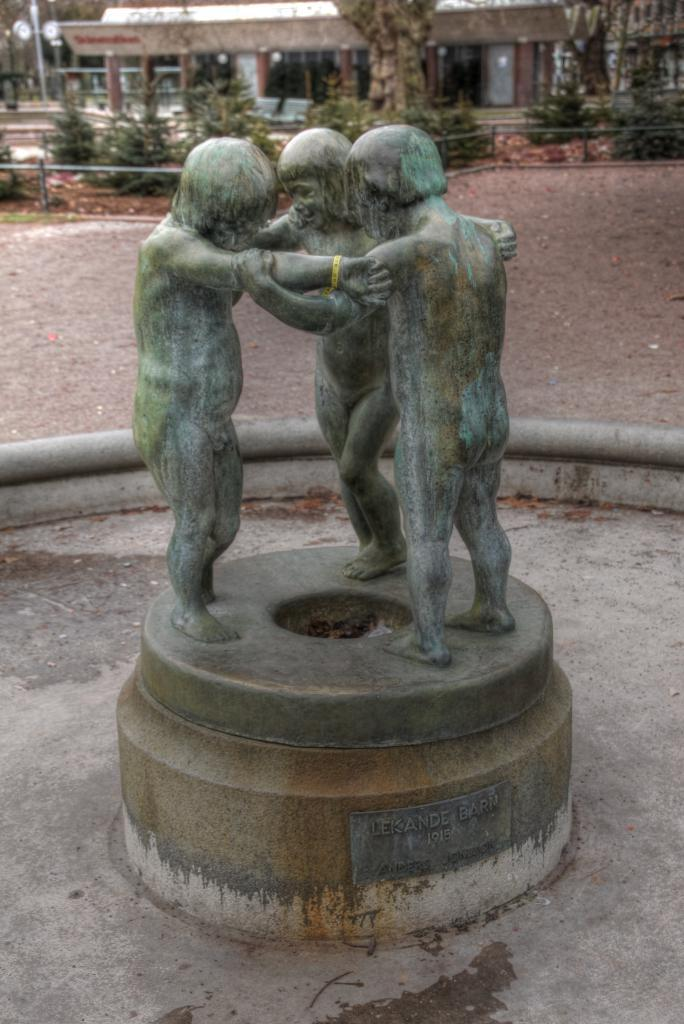What is located at the bottom of the image? There is a statue at the bottom of the image. What can be seen in the background of the image? There are trees and a building in the background of the image. Can you tell me how many farmers are visible in the image? There are no farmers present in the image. What type of education is being provided by the statue in the image? The statue is not providing any education; it is a stationary object in the image. 